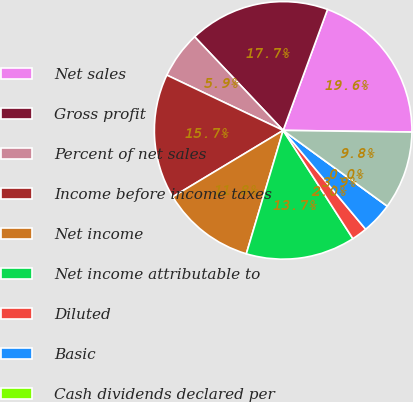<chart> <loc_0><loc_0><loc_500><loc_500><pie_chart><fcel>Net sales<fcel>Gross profit<fcel>Percent of net sales<fcel>Income before income taxes<fcel>Net income<fcel>Net income attributable to<fcel>Diluted<fcel>Basic<fcel>Cash dividends declared per<fcel>High<nl><fcel>19.61%<fcel>17.65%<fcel>5.88%<fcel>15.68%<fcel>11.76%<fcel>13.72%<fcel>1.96%<fcel>3.92%<fcel>0.0%<fcel>9.8%<nl></chart> 